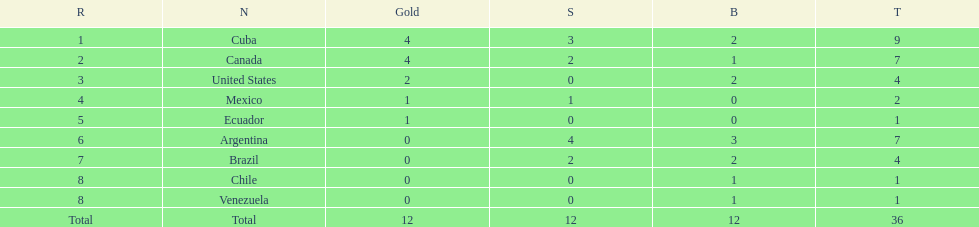How many total medals were there all together? 36. 